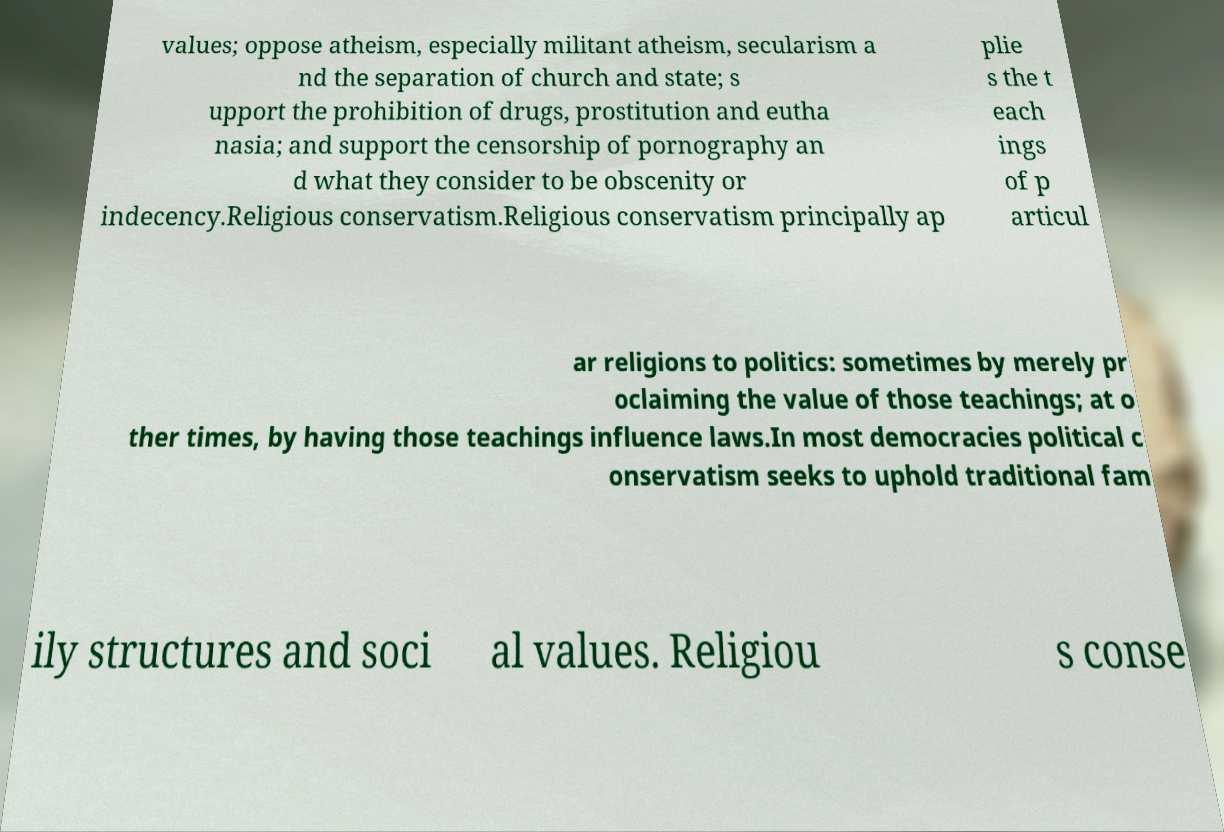Can you read and provide the text displayed in the image?This photo seems to have some interesting text. Can you extract and type it out for me? values; oppose atheism, especially militant atheism, secularism a nd the separation of church and state; s upport the prohibition of drugs, prostitution and eutha nasia; and support the censorship of pornography an d what they consider to be obscenity or indecency.Religious conservatism.Religious conservatism principally ap plie s the t each ings of p articul ar religions to politics: sometimes by merely pr oclaiming the value of those teachings; at o ther times, by having those teachings influence laws.In most democracies political c onservatism seeks to uphold traditional fam ily structures and soci al values. Religiou s conse 